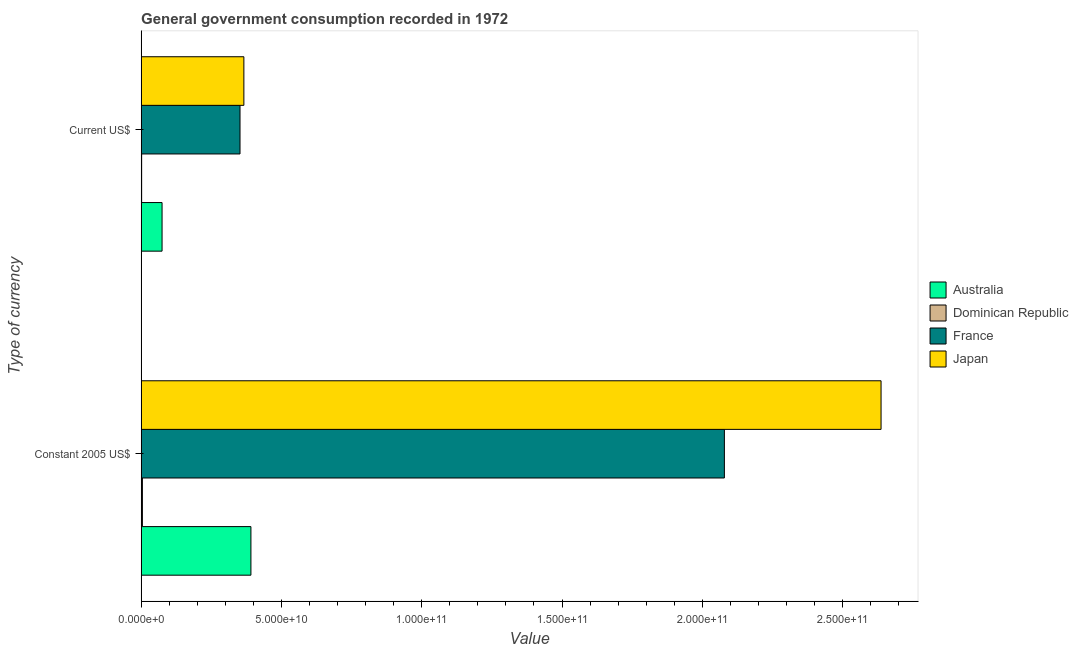Are the number of bars per tick equal to the number of legend labels?
Provide a short and direct response. Yes. How many bars are there on the 1st tick from the bottom?
Your response must be concise. 4. What is the label of the 2nd group of bars from the top?
Keep it short and to the point. Constant 2005 US$. What is the value consumed in constant 2005 us$ in France?
Give a very brief answer. 2.08e+11. Across all countries, what is the maximum value consumed in current us$?
Your response must be concise. 3.66e+1. Across all countries, what is the minimum value consumed in current us$?
Make the answer very short. 1.78e+08. In which country was the value consumed in current us$ minimum?
Provide a succinct answer. Dominican Republic. What is the total value consumed in constant 2005 us$ in the graph?
Ensure brevity in your answer.  5.11e+11. What is the difference between the value consumed in current us$ in Dominican Republic and that in Japan?
Keep it short and to the point. -3.64e+1. What is the difference between the value consumed in constant 2005 us$ in France and the value consumed in current us$ in Japan?
Ensure brevity in your answer.  1.71e+11. What is the average value consumed in current us$ per country?
Keep it short and to the point. 1.99e+1. What is the difference between the value consumed in constant 2005 us$ and value consumed in current us$ in Dominican Republic?
Keep it short and to the point. 2.72e+08. In how many countries, is the value consumed in current us$ greater than 40000000000 ?
Provide a short and direct response. 0. What is the ratio of the value consumed in constant 2005 us$ in France to that in Japan?
Provide a short and direct response. 0.79. In how many countries, is the value consumed in current us$ greater than the average value consumed in current us$ taken over all countries?
Your response must be concise. 2. What does the 2nd bar from the top in Current US$ represents?
Provide a succinct answer. France. How many bars are there?
Ensure brevity in your answer.  8. Are all the bars in the graph horizontal?
Keep it short and to the point. Yes. How many countries are there in the graph?
Offer a very short reply. 4. Are the values on the major ticks of X-axis written in scientific E-notation?
Your response must be concise. Yes. Where does the legend appear in the graph?
Your response must be concise. Center right. What is the title of the graph?
Keep it short and to the point. General government consumption recorded in 1972. What is the label or title of the X-axis?
Your response must be concise. Value. What is the label or title of the Y-axis?
Your response must be concise. Type of currency. What is the Value of Australia in Constant 2005 US$?
Make the answer very short. 3.91e+1. What is the Value of Dominican Republic in Constant 2005 US$?
Give a very brief answer. 4.49e+08. What is the Value of France in Constant 2005 US$?
Provide a succinct answer. 2.08e+11. What is the Value of Japan in Constant 2005 US$?
Your response must be concise. 2.64e+11. What is the Value in Australia in Current US$?
Make the answer very short. 7.45e+09. What is the Value in Dominican Republic in Current US$?
Offer a very short reply. 1.78e+08. What is the Value of France in Current US$?
Your response must be concise. 3.52e+1. What is the Value in Japan in Current US$?
Offer a very short reply. 3.66e+1. Across all Type of currency, what is the maximum Value in Australia?
Make the answer very short. 3.91e+1. Across all Type of currency, what is the maximum Value in Dominican Republic?
Offer a terse response. 4.49e+08. Across all Type of currency, what is the maximum Value of France?
Make the answer very short. 2.08e+11. Across all Type of currency, what is the maximum Value of Japan?
Make the answer very short. 2.64e+11. Across all Type of currency, what is the minimum Value of Australia?
Make the answer very short. 7.45e+09. Across all Type of currency, what is the minimum Value in Dominican Republic?
Offer a terse response. 1.78e+08. Across all Type of currency, what is the minimum Value in France?
Your answer should be very brief. 3.52e+1. Across all Type of currency, what is the minimum Value in Japan?
Your response must be concise. 3.66e+1. What is the total Value of Australia in the graph?
Offer a terse response. 4.66e+1. What is the total Value in Dominican Republic in the graph?
Provide a short and direct response. 6.27e+08. What is the total Value in France in the graph?
Ensure brevity in your answer.  2.43e+11. What is the total Value in Japan in the graph?
Provide a short and direct response. 3.00e+11. What is the difference between the Value of Australia in Constant 2005 US$ and that in Current US$?
Ensure brevity in your answer.  3.17e+1. What is the difference between the Value of Dominican Republic in Constant 2005 US$ and that in Current US$?
Provide a succinct answer. 2.72e+08. What is the difference between the Value in France in Constant 2005 US$ and that in Current US$?
Your answer should be compact. 1.73e+11. What is the difference between the Value of Japan in Constant 2005 US$ and that in Current US$?
Keep it short and to the point. 2.27e+11. What is the difference between the Value of Australia in Constant 2005 US$ and the Value of Dominican Republic in Current US$?
Provide a short and direct response. 3.89e+1. What is the difference between the Value of Australia in Constant 2005 US$ and the Value of France in Current US$?
Your answer should be compact. 3.88e+09. What is the difference between the Value of Australia in Constant 2005 US$ and the Value of Japan in Current US$?
Provide a succinct answer. 2.51e+09. What is the difference between the Value in Dominican Republic in Constant 2005 US$ and the Value in France in Current US$?
Offer a terse response. -3.48e+1. What is the difference between the Value of Dominican Republic in Constant 2005 US$ and the Value of Japan in Current US$?
Make the answer very short. -3.62e+1. What is the difference between the Value in France in Constant 2005 US$ and the Value in Japan in Current US$?
Keep it short and to the point. 1.71e+11. What is the average Value in Australia per Type of currency?
Offer a terse response. 2.33e+1. What is the average Value of Dominican Republic per Type of currency?
Your answer should be compact. 3.14e+08. What is the average Value of France per Type of currency?
Your answer should be very brief. 1.22e+11. What is the average Value in Japan per Type of currency?
Your response must be concise. 1.50e+11. What is the difference between the Value in Australia and Value in Dominican Republic in Constant 2005 US$?
Ensure brevity in your answer.  3.87e+1. What is the difference between the Value of Australia and Value of France in Constant 2005 US$?
Your answer should be very brief. -1.69e+11. What is the difference between the Value in Australia and Value in Japan in Constant 2005 US$?
Make the answer very short. -2.25e+11. What is the difference between the Value of Dominican Republic and Value of France in Constant 2005 US$?
Provide a succinct answer. -2.07e+11. What is the difference between the Value of Dominican Republic and Value of Japan in Constant 2005 US$?
Keep it short and to the point. -2.63e+11. What is the difference between the Value in France and Value in Japan in Constant 2005 US$?
Your answer should be very brief. -5.58e+1. What is the difference between the Value of Australia and Value of Dominican Republic in Current US$?
Ensure brevity in your answer.  7.28e+09. What is the difference between the Value in Australia and Value in France in Current US$?
Offer a terse response. -2.78e+1. What is the difference between the Value in Australia and Value in Japan in Current US$?
Make the answer very short. -2.92e+1. What is the difference between the Value of Dominican Republic and Value of France in Current US$?
Your answer should be very brief. -3.51e+1. What is the difference between the Value of Dominican Republic and Value of Japan in Current US$?
Ensure brevity in your answer.  -3.64e+1. What is the difference between the Value of France and Value of Japan in Current US$?
Offer a very short reply. -1.38e+09. What is the ratio of the Value of Australia in Constant 2005 US$ to that in Current US$?
Give a very brief answer. 5.25. What is the ratio of the Value of Dominican Republic in Constant 2005 US$ to that in Current US$?
Provide a short and direct response. 2.53. What is the ratio of the Value in France in Constant 2005 US$ to that in Current US$?
Keep it short and to the point. 5.9. What is the ratio of the Value of Japan in Constant 2005 US$ to that in Current US$?
Keep it short and to the point. 7.2. What is the difference between the highest and the second highest Value of Australia?
Offer a terse response. 3.17e+1. What is the difference between the highest and the second highest Value of Dominican Republic?
Keep it short and to the point. 2.72e+08. What is the difference between the highest and the second highest Value in France?
Your answer should be very brief. 1.73e+11. What is the difference between the highest and the second highest Value in Japan?
Your answer should be very brief. 2.27e+11. What is the difference between the highest and the lowest Value of Australia?
Ensure brevity in your answer.  3.17e+1. What is the difference between the highest and the lowest Value of Dominican Republic?
Offer a terse response. 2.72e+08. What is the difference between the highest and the lowest Value of France?
Your response must be concise. 1.73e+11. What is the difference between the highest and the lowest Value of Japan?
Your response must be concise. 2.27e+11. 